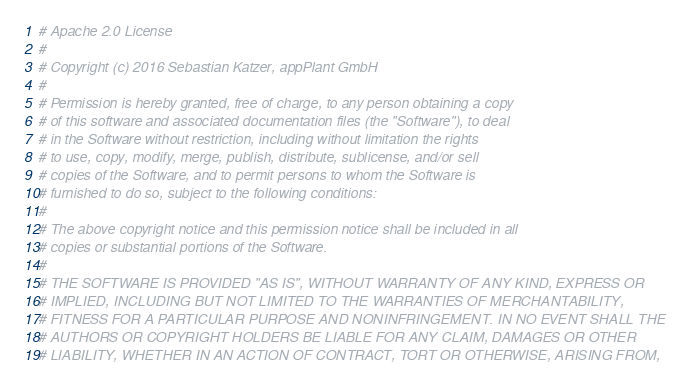<code> <loc_0><loc_0><loc_500><loc_500><_Ruby_># Apache 2.0 License
#
# Copyright (c) 2016 Sebastian Katzer, appPlant GmbH
#
# Permission is hereby granted, free of charge, to any person obtaining a copy
# of this software and associated documentation files (the "Software"), to deal
# in the Software without restriction, including without limitation the rights
# to use, copy, modify, merge, publish, distribute, sublicense, and/or sell
# copies of the Software, and to permit persons to whom the Software is
# furnished to do so, subject to the following conditions:
#
# The above copyright notice and this permission notice shall be included in all
# copies or substantial portions of the Software.
#
# THE SOFTWARE IS PROVIDED "AS IS", WITHOUT WARRANTY OF ANY KIND, EXPRESS OR
# IMPLIED, INCLUDING BUT NOT LIMITED TO THE WARRANTIES OF MERCHANTABILITY,
# FITNESS FOR A PARTICULAR PURPOSE AND NONINFRINGEMENT. IN NO EVENT SHALL THE
# AUTHORS OR COPYRIGHT HOLDERS BE LIABLE FOR ANY CLAIM, DAMAGES OR OTHER
# LIABILITY, WHETHER IN AN ACTION OF CONTRACT, TORT OR OTHERWISE, ARISING FROM,</code> 